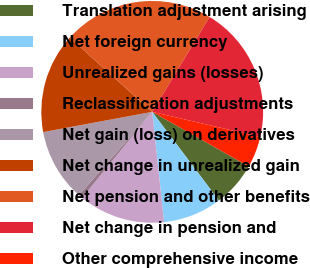Convert chart. <chart><loc_0><loc_0><loc_500><loc_500><pie_chart><fcel>Translation adjustment arising<fcel>Net foreign currency<fcel>Unrealized gains (losses)<fcel>Reclassification adjustments<fcel>Net gain (loss) on derivatives<fcel>Net change in unrealized gain<fcel>Net pension and other benefits<fcel>Net change in pension and<fcel>Other comprehensive income<nl><fcel>6.55%<fcel>8.56%<fcel>12.58%<fcel>0.63%<fcel>10.57%<fcel>14.59%<fcel>21.99%<fcel>19.98%<fcel>4.55%<nl></chart> 